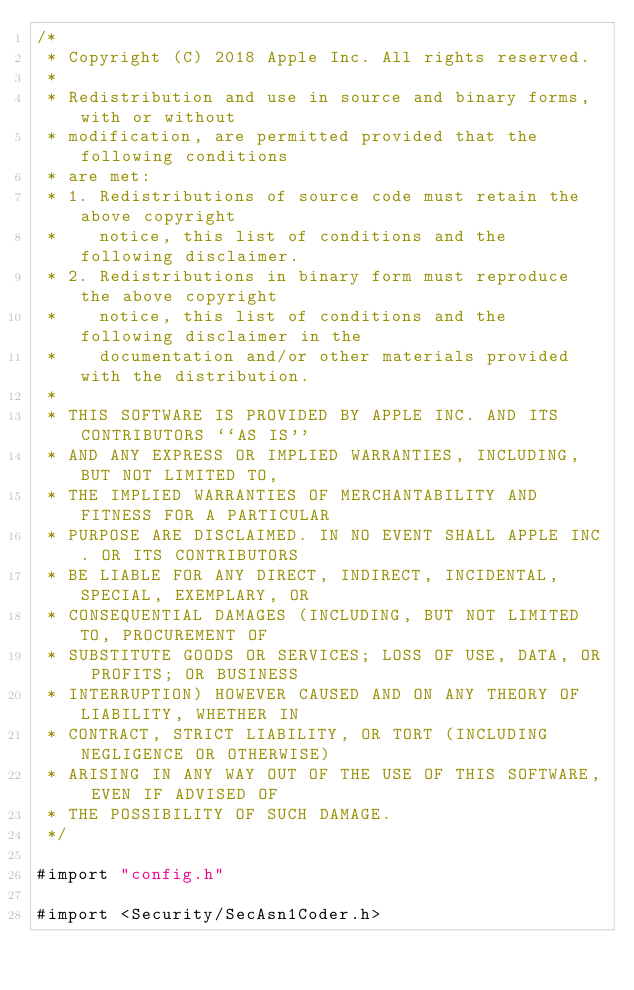Convert code to text. <code><loc_0><loc_0><loc_500><loc_500><_ObjectiveC_>/*
 * Copyright (C) 2018 Apple Inc. All rights reserved.
 *
 * Redistribution and use in source and binary forms, with or without
 * modification, are permitted provided that the following conditions
 * are met:
 * 1. Redistributions of source code must retain the above copyright
 *    notice, this list of conditions and the following disclaimer.
 * 2. Redistributions in binary form must reproduce the above copyright
 *    notice, this list of conditions and the following disclaimer in the
 *    documentation and/or other materials provided with the distribution.
 *
 * THIS SOFTWARE IS PROVIDED BY APPLE INC. AND ITS CONTRIBUTORS ``AS IS''
 * AND ANY EXPRESS OR IMPLIED WARRANTIES, INCLUDING, BUT NOT LIMITED TO,
 * THE IMPLIED WARRANTIES OF MERCHANTABILITY AND FITNESS FOR A PARTICULAR
 * PURPOSE ARE DISCLAIMED. IN NO EVENT SHALL APPLE INC. OR ITS CONTRIBUTORS
 * BE LIABLE FOR ANY DIRECT, INDIRECT, INCIDENTAL, SPECIAL, EXEMPLARY, OR
 * CONSEQUENTIAL DAMAGES (INCLUDING, BUT NOT LIMITED TO, PROCUREMENT OF
 * SUBSTITUTE GOODS OR SERVICES; LOSS OF USE, DATA, OR PROFITS; OR BUSINESS
 * INTERRUPTION) HOWEVER CAUSED AND ON ANY THEORY OF LIABILITY, WHETHER IN
 * CONTRACT, STRICT LIABILITY, OR TORT (INCLUDING NEGLIGENCE OR OTHERWISE)
 * ARISING IN ANY WAY OUT OF THE USE OF THIS SOFTWARE, EVEN IF ADVISED OF
 * THE POSSIBILITY OF SUCH DAMAGE.
 */

#import "config.h"

#import <Security/SecAsn1Coder.h></code> 